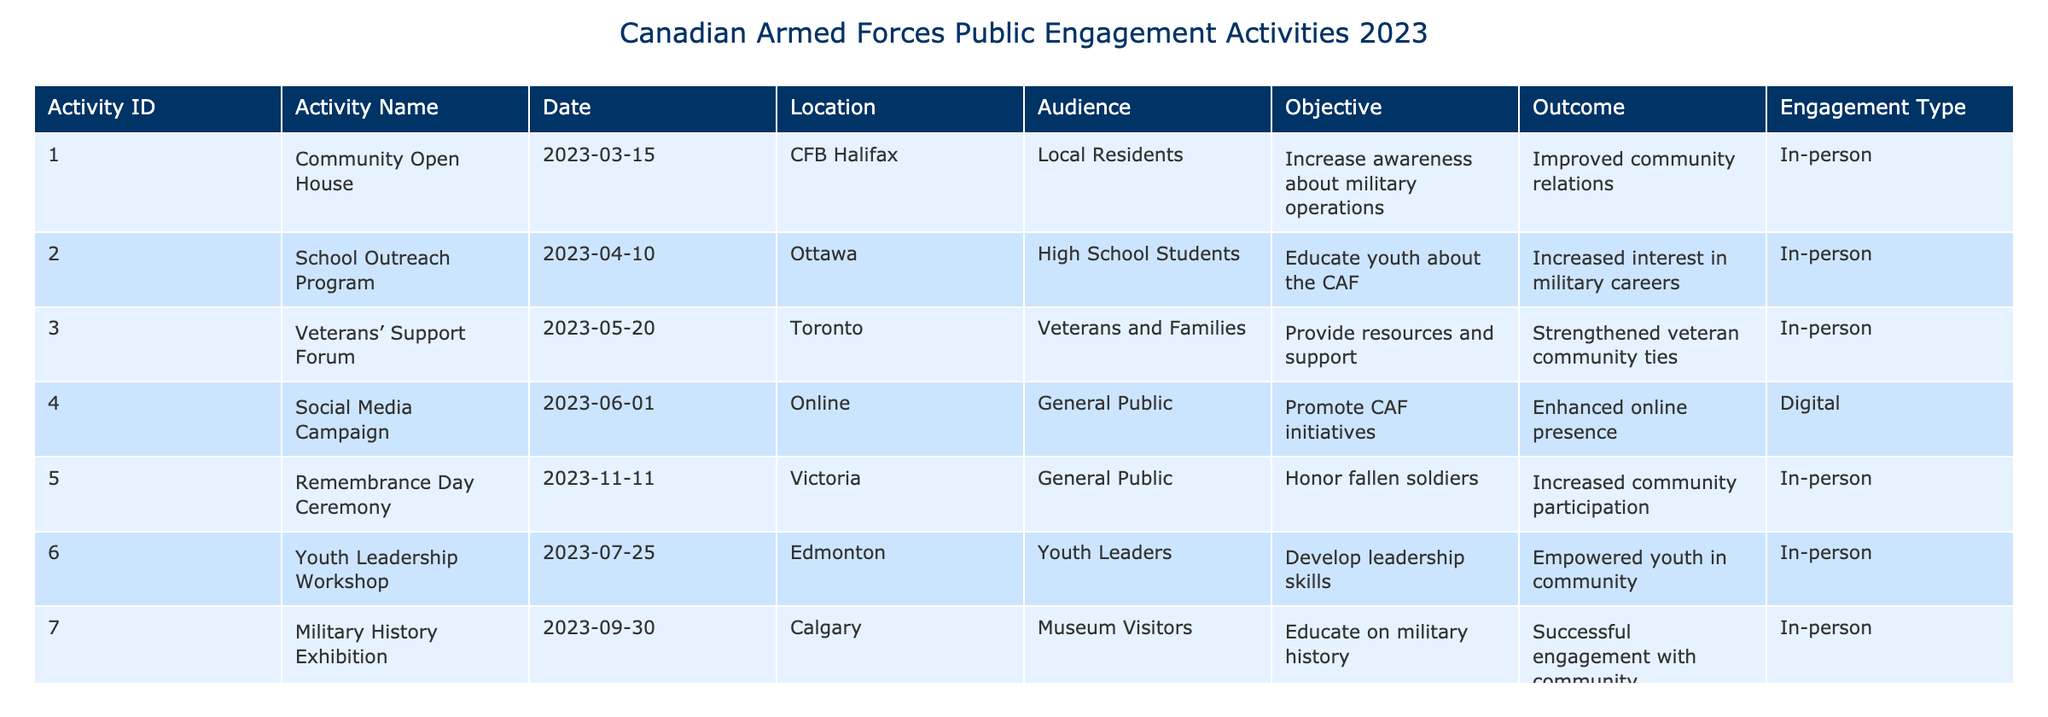What was the date of the Veterans' Support Forum? The table lists the details of various activities. The Veterans' Support Forum is mentioned in row 3, and the date given there is 2023-05-20.
Answer: 2023-05-20 Which activity targeted high school students? The table shows that the School Outreach Program is aimed at high school students, found in row 2.
Answer: School Outreach Program How many in-person events were organized by the Canadian Armed Forces? By reviewing the engagement type column, we count the number of "In-person" entries: there are 6 in-person events (Activities ID 1, 2, 3, 5, 6, and 7).
Answer: 6 Is there a digital engagement activity noted in the table? The table shows an entry with "Digital" under the engagement type for the Social Media Campaign, indicating a digital activity exists.
Answer: Yes What was the objective of the Recruitment Information Session? The objective for the Recruitment Information Session, listed as Activity ID 8, is to attract new recruits according to the corresponding row in the table.
Answer: Attract new recruits What is the total number of distinct audiences targeted in the activities? By examining the audience column, we identify the unique audiences as Local Residents, High School Students, Veterans and Families, General Public, Youth Leaders, and Job Seekers, totaling 6 distinct groups.
Answer: 6 Which activity resulted in strengthened veteran community ties? The Veterans' Support Forum, identified in row 3, aimed to provide resources and support, with the outcome specified as strengthened veteran community ties.
Answer: Veterans' Support Forum Which city hosted the Youth Leadership Workshop? Looking at the location column for Activity ID 6, we find that the Youth Leadership Workshop took place in Edmonton.
Answer: Edmonton What was the outcome of the Social Media Campaign? According to row 4 in the table, the outcome of the Social Media Campaign was an enhanced online presence.
Answer: Enhanced online presence 